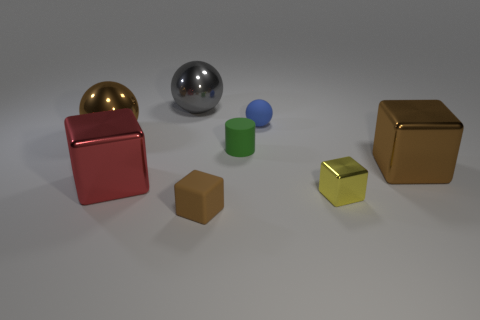What shape is the small brown object that is on the left side of the big brown metallic object in front of the brown thing left of the red metal object?
Offer a very short reply. Cube. There is a large metallic sphere on the left side of the gray object; does it have the same color as the big metal block that is right of the tiny matte cylinder?
Give a very brief answer. Yes. Are there fewer small brown rubber cubes in front of the brown matte object than large balls to the right of the big brown ball?
Make the answer very short. Yes. Is there anything else that has the same shape as the green matte thing?
Provide a short and direct response. No. What color is the other large thing that is the same shape as the large red metal object?
Your response must be concise. Brown. There is a yellow metallic object; is its shape the same as the brown metallic object right of the matte sphere?
Offer a terse response. Yes. How many things are tiny metallic things that are in front of the big brown ball or cubes that are to the left of the blue rubber sphere?
Offer a very short reply. 3. What material is the yellow thing?
Offer a very short reply. Metal. How many other objects are there of the same size as the yellow block?
Give a very brief answer. 3. There is a brown block that is to the left of the brown metallic block; what size is it?
Make the answer very short. Small. 